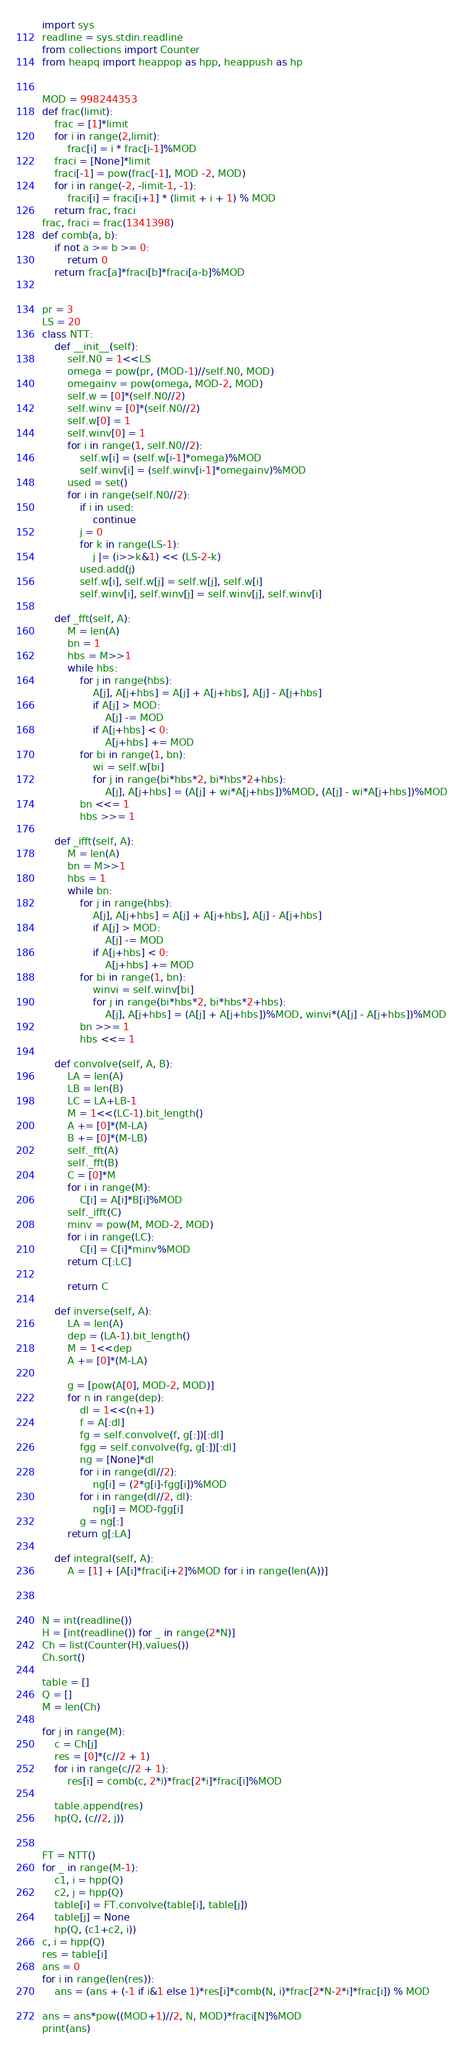<code> <loc_0><loc_0><loc_500><loc_500><_Python_>import sys
readline = sys.stdin.readline
from collections import Counter
from heapq import heappop as hpp, heappush as hp


MOD = 998244353
def frac(limit):
    frac = [1]*limit
    for i in range(2,limit):
        frac[i] = i * frac[i-1]%MOD
    fraci = [None]*limit
    fraci[-1] = pow(frac[-1], MOD -2, MOD)
    for i in range(-2, -limit-1, -1):
        fraci[i] = fraci[i+1] * (limit + i + 1) % MOD
    return frac, fraci
frac, fraci = frac(1341398)
def comb(a, b):
    if not a >= b >= 0:
        return 0
    return frac[a]*fraci[b]*fraci[a-b]%MOD


pr = 3
LS = 20
class NTT:
    def __init__(self):
        self.N0 = 1<<LS
        omega = pow(pr, (MOD-1)//self.N0, MOD)
        omegainv = pow(omega, MOD-2, MOD)
        self.w = [0]*(self.N0//2)
        self.winv = [0]*(self.N0//2)
        self.w[0] = 1
        self.winv[0] = 1
        for i in range(1, self.N0//2):
            self.w[i] = (self.w[i-1]*omega)%MOD
            self.winv[i] = (self.winv[i-1]*omegainv)%MOD
        used = set()
        for i in range(self.N0//2):
            if i in used:
                continue
            j = 0
            for k in range(LS-1):
                j |= (i>>k&1) << (LS-2-k)
            used.add(j)
            self.w[i], self.w[j] = self.w[j], self.w[i]
            self.winv[i], self.winv[j] = self.winv[j], self.winv[i]
        
    def _fft(self, A):
        M = len(A)
        bn = 1
        hbs = M>>1
        while hbs:
            for j in range(hbs):
                A[j], A[j+hbs] = A[j] + A[j+hbs], A[j] - A[j+hbs]
                if A[j] > MOD:
                    A[j] -= MOD
                if A[j+hbs] < 0:
                    A[j+hbs] += MOD
            for bi in range(1, bn):
                wi = self.w[bi]
                for j in range(bi*hbs*2, bi*hbs*2+hbs):
                    A[j], A[j+hbs] = (A[j] + wi*A[j+hbs])%MOD, (A[j] - wi*A[j+hbs])%MOD
            bn <<= 1
            hbs >>= 1

    def _ifft(self, A):
        M = len(A)
        bn = M>>1
        hbs = 1
        while bn:
            for j in range(hbs):
                A[j], A[j+hbs] = A[j] + A[j+hbs], A[j] - A[j+hbs]
                if A[j] > MOD:
                    A[j] -= MOD
                if A[j+hbs] < 0:
                    A[j+hbs] += MOD
            for bi in range(1, bn):
                winvi = self.winv[bi]
                for j in range(bi*hbs*2, bi*hbs*2+hbs):
                    A[j], A[j+hbs] = (A[j] + A[j+hbs])%MOD, winvi*(A[j] - A[j+hbs])%MOD
            bn >>= 1
            hbs <<= 1
    
    def convolve(self, A, B):
        LA = len(A)
        LB = len(B)
        LC = LA+LB-1
        M = 1<<(LC-1).bit_length()
        A += [0]*(M-LA)
        B += [0]*(M-LB)
        self._fft(A)
        self._fft(B)
        C = [0]*M
        for i in range(M):
            C[i] = A[i]*B[i]%MOD
        self._ifft(C)
        minv = pow(M, MOD-2, MOD)
        for i in range(LC):
            C[i] = C[i]*minv%MOD
        return C[:LC]
        
        return C
    
    def inverse(self, A):
        LA = len(A)
        dep = (LA-1).bit_length()
        M = 1<<dep
        A += [0]*(M-LA)
        
        g = [pow(A[0], MOD-2, MOD)]
        for n in range(dep):
            dl = 1<<(n+1)
            f = A[:dl]
            fg = self.convolve(f, g[:])[:dl]
            fgg = self.convolve(fg, g[:])[:dl]
            ng = [None]*dl
            for i in range(dl//2):
                ng[i] = (2*g[i]-fgg[i])%MOD
            for i in range(dl//2, dl):
                ng[i] = MOD-fgg[i]
            g = ng[:]
        return g[:LA]
    
    def integral(self, A):
        A = [1] + [A[i]*fraci[i+2]%MOD for i in range(len(A))]



N = int(readline())
H = [int(readline()) for _ in range(2*N)]
Ch = list(Counter(H).values())
Ch.sort()

table = []
Q = []
M = len(Ch)

for j in range(M):
    c = Ch[j]
    res = [0]*(c//2 + 1)
    for i in range(c//2 + 1):
        res[i] = comb(c, 2*i)*frac[2*i]*fraci[i]%MOD

    table.append(res)
    hp(Q, (c//2, j))


FT = NTT()
for _ in range(M-1):
    c1, i = hpp(Q)
    c2, j = hpp(Q)
    table[i] = FT.convolve(table[i], table[j])
    table[j] = None
    hp(Q, (c1+c2, i))
c, i = hpp(Q)
res = table[i]
ans = 0
for i in range(len(res)):
    ans = (ans + (-1 if i&1 else 1)*res[i]*comb(N, i)*frac[2*N-2*i]*frac[i]) % MOD

ans = ans*pow((MOD+1)//2, N, MOD)*fraci[N]%MOD
print(ans)</code> 